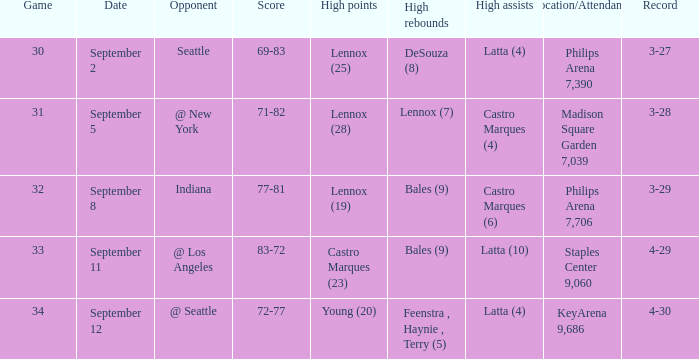When did indiana play? September 8. 